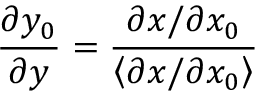Convert formula to latex. <formula><loc_0><loc_0><loc_500><loc_500>\frac { \partial y _ { 0 } } { \partial y } = \frac { \partial x / \partial x _ { 0 } } { \left \langle \partial x / \partial x _ { 0 } \right \rangle }</formula> 